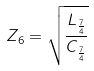<formula> <loc_0><loc_0><loc_500><loc_500>Z _ { 6 } = \sqrt { \frac { L _ { \frac { 7 } { 4 } } } { C _ { \frac { 7 } { 4 } } } }</formula> 